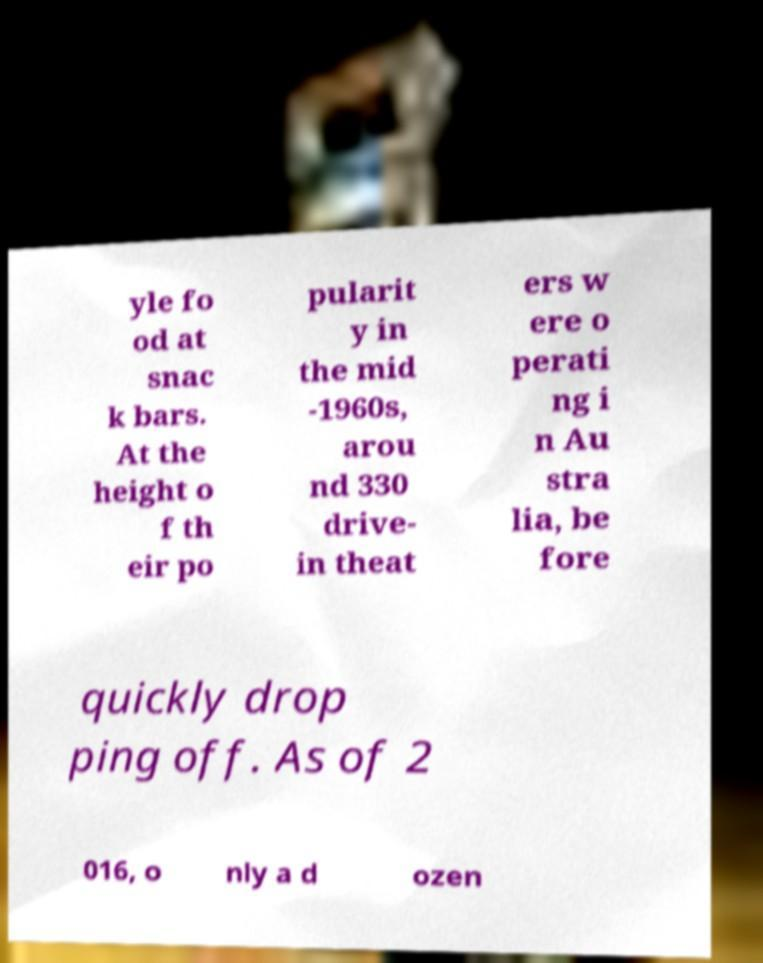Please read and relay the text visible in this image. What does it say? yle fo od at snac k bars. At the height o f th eir po pularit y in the mid -1960s, arou nd 330 drive- in theat ers w ere o perati ng i n Au stra lia, be fore quickly drop ping off. As of 2 016, o nly a d ozen 